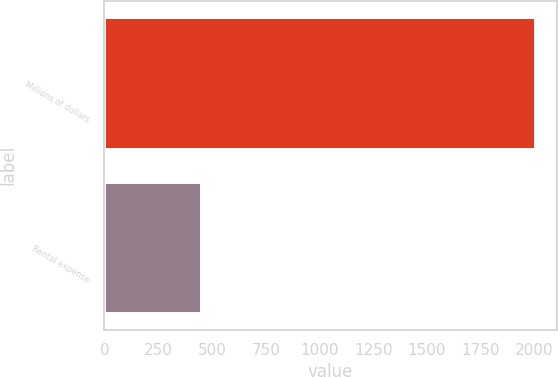<chart> <loc_0><loc_0><loc_500><loc_500><bar_chart><fcel>Millions of dollars<fcel>Rental expense<nl><fcel>2003<fcel>451<nl></chart> 